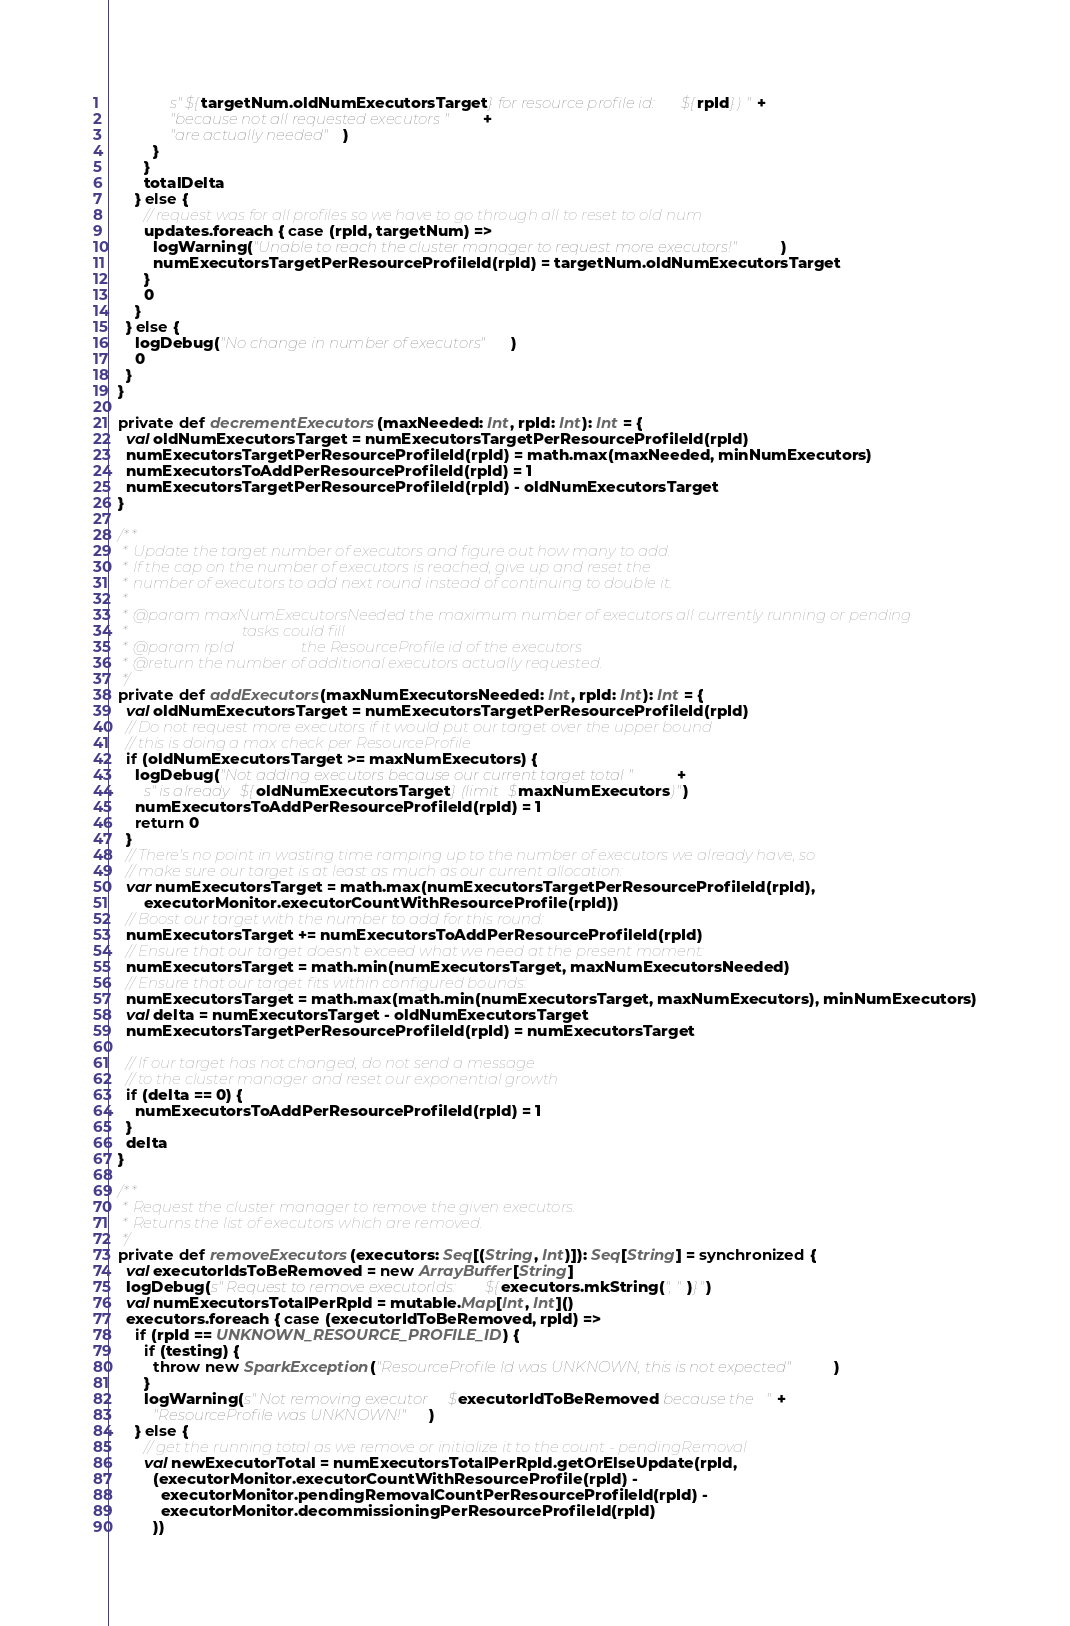<code> <loc_0><loc_0><loc_500><loc_500><_Scala_>              s"${targetNum.oldNumExecutorsTarget} for resource profile id: ${rpId}) " +
              "because not all requested executors " +
              "are actually needed")
          }
        }
        totalDelta
      } else {
        // request was for all profiles so we have to go through all to reset to old num
        updates.foreach { case (rpId, targetNum) =>
          logWarning("Unable to reach the cluster manager to request more executors!")
          numExecutorsTargetPerResourceProfileId(rpId) = targetNum.oldNumExecutorsTarget
        }
        0
      }
    } else {
      logDebug("No change in number of executors")
      0
    }
  }

  private def decrementExecutors(maxNeeded: Int, rpId: Int): Int = {
    val oldNumExecutorsTarget = numExecutorsTargetPerResourceProfileId(rpId)
    numExecutorsTargetPerResourceProfileId(rpId) = math.max(maxNeeded, minNumExecutors)
    numExecutorsToAddPerResourceProfileId(rpId) = 1
    numExecutorsTargetPerResourceProfileId(rpId) - oldNumExecutorsTarget
  }

  /**
   * Update the target number of executors and figure out how many to add.
   * If the cap on the number of executors is reached, give up and reset the
   * number of executors to add next round instead of continuing to double it.
   *
   * @param maxNumExecutorsNeeded the maximum number of executors all currently running or pending
   *                              tasks could fill
   * @param rpId                  the ResourceProfile id of the executors
   * @return the number of additional executors actually requested.
   */
  private def addExecutors(maxNumExecutorsNeeded: Int, rpId: Int): Int = {
    val oldNumExecutorsTarget = numExecutorsTargetPerResourceProfileId(rpId)
    // Do not request more executors if it would put our target over the upper bound
    // this is doing a max check per ResourceProfile
    if (oldNumExecutorsTarget >= maxNumExecutors) {
      logDebug("Not adding executors because our current target total " +
        s"is already ${oldNumExecutorsTarget} (limit $maxNumExecutors)")
      numExecutorsToAddPerResourceProfileId(rpId) = 1
      return 0
    }
    // There's no point in wasting time ramping up to the number of executors we already have, so
    // make sure our target is at least as much as our current allocation:
    var numExecutorsTarget = math.max(numExecutorsTargetPerResourceProfileId(rpId),
        executorMonitor.executorCountWithResourceProfile(rpId))
    // Boost our target with the number to add for this round:
    numExecutorsTarget += numExecutorsToAddPerResourceProfileId(rpId)
    // Ensure that our target doesn't exceed what we need at the present moment:
    numExecutorsTarget = math.min(numExecutorsTarget, maxNumExecutorsNeeded)
    // Ensure that our target fits within configured bounds:
    numExecutorsTarget = math.max(math.min(numExecutorsTarget, maxNumExecutors), minNumExecutors)
    val delta = numExecutorsTarget - oldNumExecutorsTarget
    numExecutorsTargetPerResourceProfileId(rpId) = numExecutorsTarget

    // If our target has not changed, do not send a message
    // to the cluster manager and reset our exponential growth
    if (delta == 0) {
      numExecutorsToAddPerResourceProfileId(rpId) = 1
    }
    delta
  }

  /**
   * Request the cluster manager to remove the given executors.
   * Returns the list of executors which are removed.
   */
  private def removeExecutors(executors: Seq[(String, Int)]): Seq[String] = synchronized {
    val executorIdsToBeRemoved = new ArrayBuffer[String]
    logDebug(s"Request to remove executorIds: ${executors.mkString(", ")}")
    val numExecutorsTotalPerRpId = mutable.Map[Int, Int]()
    executors.foreach { case (executorIdToBeRemoved, rpId) =>
      if (rpId == UNKNOWN_RESOURCE_PROFILE_ID) {
        if (testing) {
          throw new SparkException("ResourceProfile Id was UNKNOWN, this is not expected")
        }
        logWarning(s"Not removing executor $executorIdToBeRemoved because the " +
          "ResourceProfile was UNKNOWN!")
      } else {
        // get the running total as we remove or initialize it to the count - pendingRemoval
        val newExecutorTotal = numExecutorsTotalPerRpId.getOrElseUpdate(rpId,
          (executorMonitor.executorCountWithResourceProfile(rpId) -
            executorMonitor.pendingRemovalCountPerResourceProfileId(rpId) -
            executorMonitor.decommissioningPerResourceProfileId(rpId)
          ))</code> 